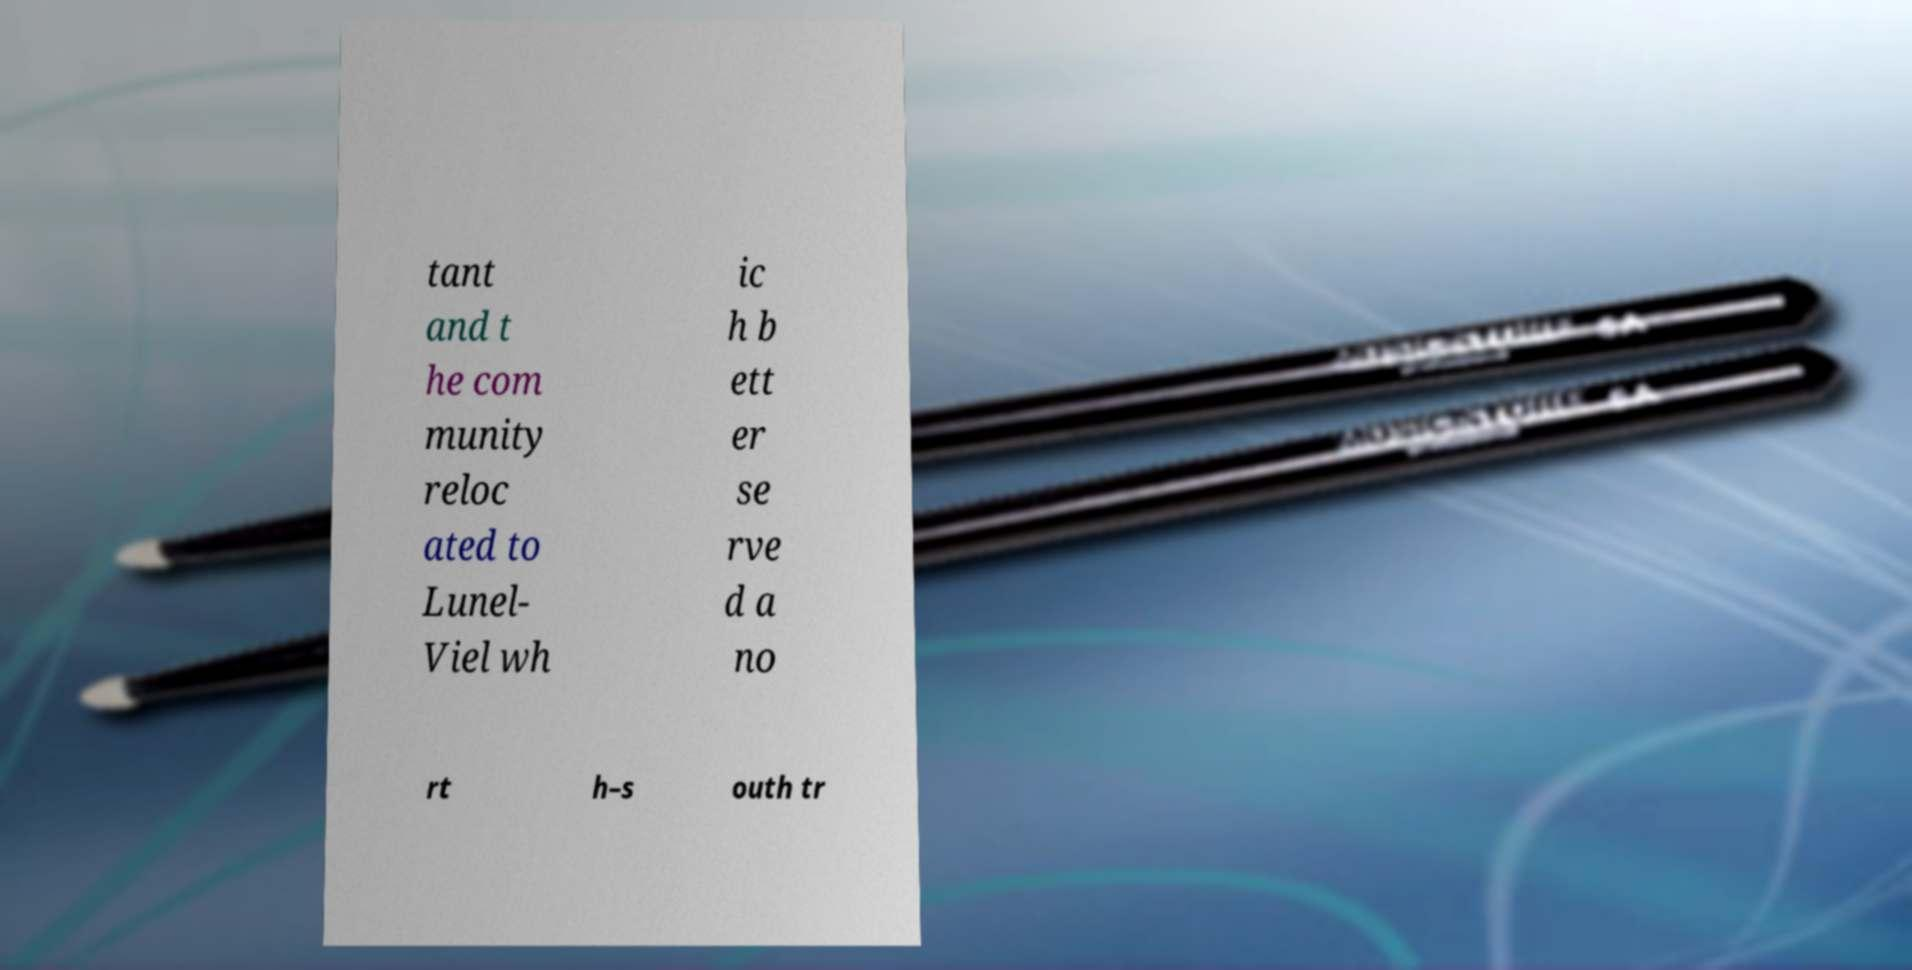Can you read and provide the text displayed in the image?This photo seems to have some interesting text. Can you extract and type it out for me? tant and t he com munity reloc ated to Lunel- Viel wh ic h b ett er se rve d a no rt h–s outh tr 